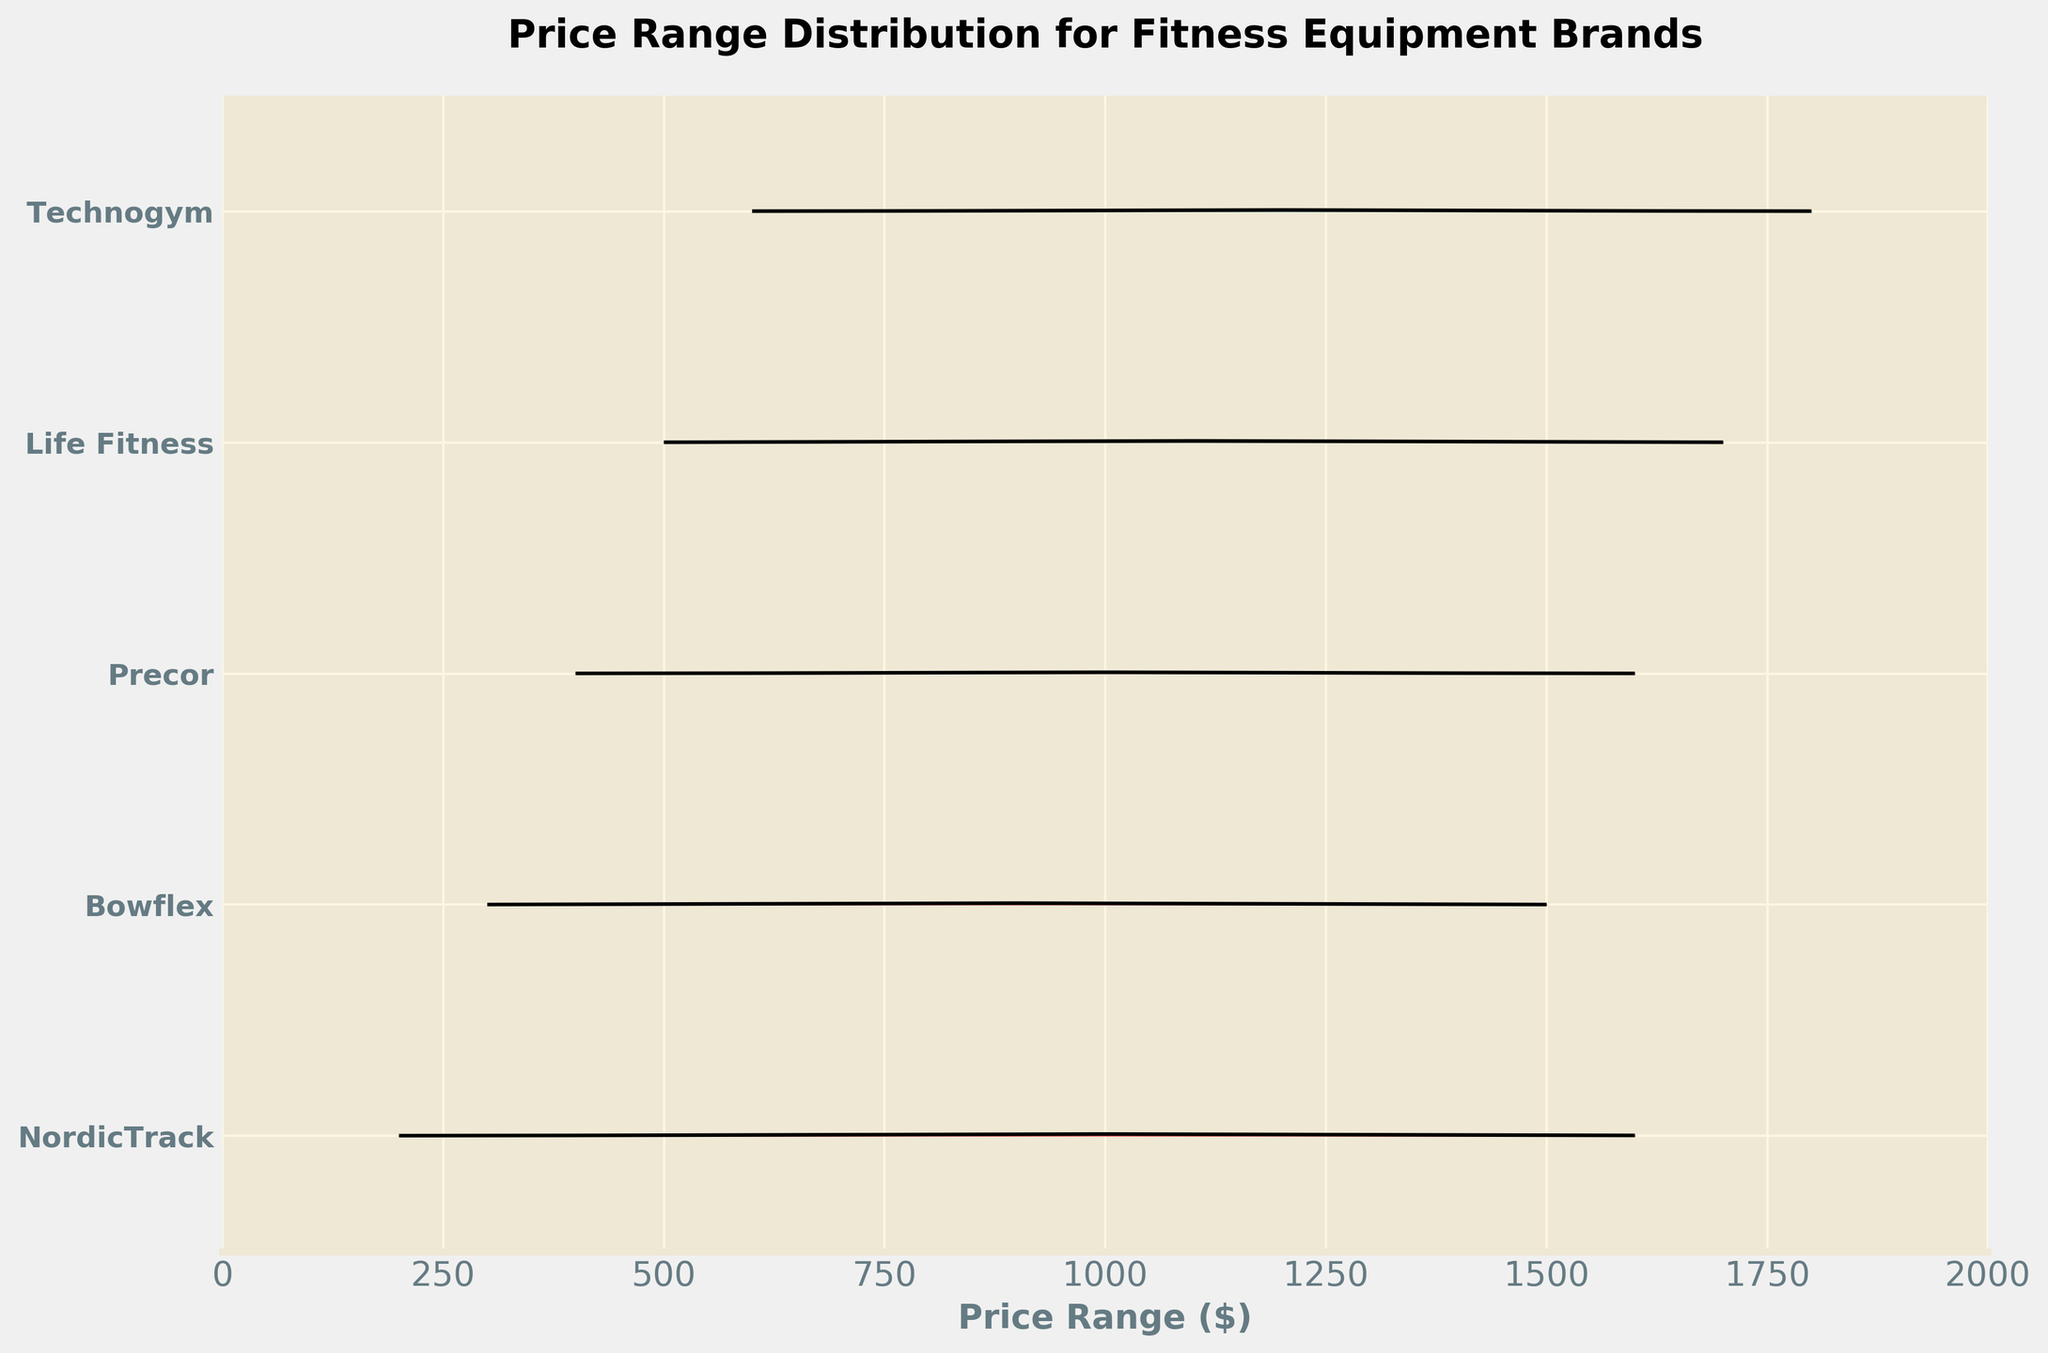what is the brand with the highest peak density in the price range distribution? The brand with the highest peak density is the one where the curve reaches the highest point on the y-axis. NordicTrack reaches a peak density of 0.008 at $1000.
Answer: NordicTrack What is the price range where Bowflex's distribution has its highest density? To find this, locate where Bowflex's curve has the highest point. Bowflex reaches its highest density of 0.007 around the price range of $900.
Answer: $900 Which brand has the largest spread in the price range distribution? A brand with a large spread will have its distribution curve spanning a large range on the x-axis. Technogym’s distribution appears to spread the most, from around $600 to $1800.
Answer: Technogym What is the common price characteristic among all brands, if any? Examine the x-axis for any price range covered by all brands' distributions. All brands have a density in the $1000 price range.
Answer: $1000 Which brand has the most symmetrical distribution of price ranges around its peak? Symmetry means that the distribution curve falls off on both sides of its peak density in a similar pattern. NordicTrack shows a fairly symmetrical curve around its peak at $1000.
Answer: NordicTrack Compare the peaks of NordicTrack and Life Fitness. Which is higher and at what price ranges are they? Check where each brand’s curve peaks. NordicTrack peaks at a higher density (0.008 at $1000) compared to Life Fitness (0.007 at $1100).
Answer: NordicTrack is higher, at $1000 How does Technogym's price distribution compare to that of Precor in terms of spread and focus? Technogym has a wider spread (covers $600 to $1800) and a less focused density than Precor which has its peak density around $1000 and a relatively narrower spread from $400 to $1600.
Answer: Technogym is wider and less focused Is there any brand that has a declining trend in density with an increase in price? Look for a curve where density consistently decreases as the price range increases. None of the brands show a consistent declining trend; their curves generally peak and then fall off.
Answer: No Which brands share the exact same peak density and very similar price ranges for their peaks? Compare the peak densities and price ranges for each brand. NordicTrack and Life Fitness both peak at a density of 0.007, but they do so at different price ranges ($1000 vs. $1100).
Answer: None 